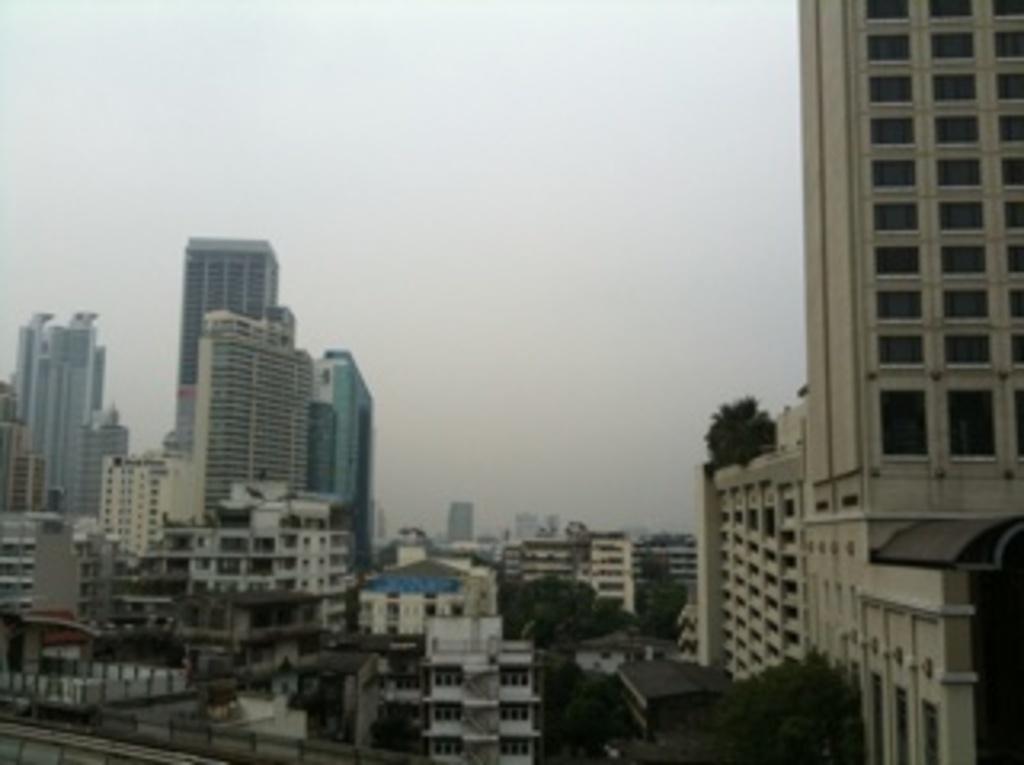How would you summarize this image in a sentence or two? In this picture we can see few buildings and trees. 